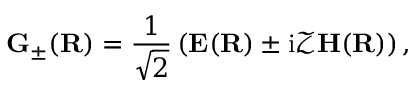<formula> <loc_0><loc_0><loc_500><loc_500>\mathbf G _ { \pm } ( \mathbf R ) = \frac { 1 } { \sqrt { 2 } } \left ( \mathbf E ( \mathbf R ) \pm i \mathcal { Z } \mathbf H ( \mathbf R ) \right ) ,</formula> 